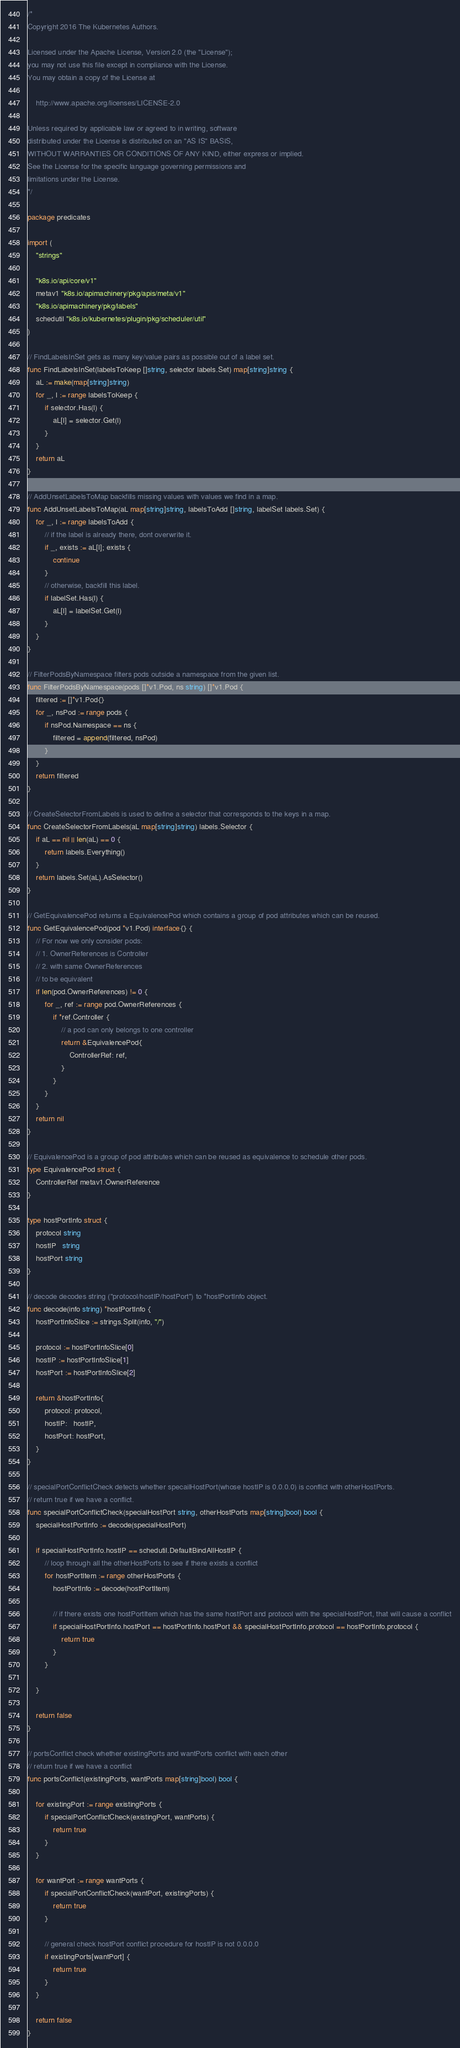<code> <loc_0><loc_0><loc_500><loc_500><_Go_>/*
Copyright 2016 The Kubernetes Authors.

Licensed under the Apache License, Version 2.0 (the "License");
you may not use this file except in compliance with the License.
You may obtain a copy of the License at

    http://www.apache.org/licenses/LICENSE-2.0

Unless required by applicable law or agreed to in writing, software
distributed under the License is distributed on an "AS IS" BASIS,
WITHOUT WARRANTIES OR CONDITIONS OF ANY KIND, either express or implied.
See the License for the specific language governing permissions and
limitations under the License.
*/

package predicates

import (
	"strings"

	"k8s.io/api/core/v1"
	metav1 "k8s.io/apimachinery/pkg/apis/meta/v1"
	"k8s.io/apimachinery/pkg/labels"
	schedutil "k8s.io/kubernetes/plugin/pkg/scheduler/util"
)

// FindLabelsInSet gets as many key/value pairs as possible out of a label set.
func FindLabelsInSet(labelsToKeep []string, selector labels.Set) map[string]string {
	aL := make(map[string]string)
	for _, l := range labelsToKeep {
		if selector.Has(l) {
			aL[l] = selector.Get(l)
		}
	}
	return aL
}

// AddUnsetLabelsToMap backfills missing values with values we find in a map.
func AddUnsetLabelsToMap(aL map[string]string, labelsToAdd []string, labelSet labels.Set) {
	for _, l := range labelsToAdd {
		// if the label is already there, dont overwrite it.
		if _, exists := aL[l]; exists {
			continue
		}
		// otherwise, backfill this label.
		if labelSet.Has(l) {
			aL[l] = labelSet.Get(l)
		}
	}
}

// FilterPodsByNamespace filters pods outside a namespace from the given list.
func FilterPodsByNamespace(pods []*v1.Pod, ns string) []*v1.Pod {
	filtered := []*v1.Pod{}
	for _, nsPod := range pods {
		if nsPod.Namespace == ns {
			filtered = append(filtered, nsPod)
		}
	}
	return filtered
}

// CreateSelectorFromLabels is used to define a selector that corresponds to the keys in a map.
func CreateSelectorFromLabels(aL map[string]string) labels.Selector {
	if aL == nil || len(aL) == 0 {
		return labels.Everything()
	}
	return labels.Set(aL).AsSelector()
}

// GetEquivalencePod returns a EquivalencePod which contains a group of pod attributes which can be reused.
func GetEquivalencePod(pod *v1.Pod) interface{} {
	// For now we only consider pods:
	// 1. OwnerReferences is Controller
	// 2. with same OwnerReferences
	// to be equivalent
	if len(pod.OwnerReferences) != 0 {
		for _, ref := range pod.OwnerReferences {
			if *ref.Controller {
				// a pod can only belongs to one controller
				return &EquivalencePod{
					ControllerRef: ref,
				}
			}
		}
	}
	return nil
}

// EquivalencePod is a group of pod attributes which can be reused as equivalence to schedule other pods.
type EquivalencePod struct {
	ControllerRef metav1.OwnerReference
}

type hostPortInfo struct {
	protocol string
	hostIP   string
	hostPort string
}

// decode decodes string ("protocol/hostIP/hostPort") to *hostPortInfo object.
func decode(info string) *hostPortInfo {
	hostPortInfoSlice := strings.Split(info, "/")

	protocol := hostPortInfoSlice[0]
	hostIP := hostPortInfoSlice[1]
	hostPort := hostPortInfoSlice[2]

	return &hostPortInfo{
		protocol: protocol,
		hostIP:   hostIP,
		hostPort: hostPort,
	}
}

// specialPortConflictCheck detects whether specailHostPort(whose hostIP is 0.0.0.0) is conflict with otherHostPorts.
// return true if we have a conflict.
func specialPortConflictCheck(specialHostPort string, otherHostPorts map[string]bool) bool {
	specialHostPortInfo := decode(specialHostPort)

	if specialHostPortInfo.hostIP == schedutil.DefaultBindAllHostIP {
		// loop through all the otherHostPorts to see if there exists a conflict
		for hostPortItem := range otherHostPorts {
			hostPortInfo := decode(hostPortItem)

			// if there exists one hostPortItem which has the same hostPort and protocol with the specialHostPort, that will cause a conflict
			if specialHostPortInfo.hostPort == hostPortInfo.hostPort && specialHostPortInfo.protocol == hostPortInfo.protocol {
				return true
			}
		}

	}

	return false
}

// portsConflict check whether existingPorts and wantPorts conflict with each other
// return true if we have a conflict
func portsConflict(existingPorts, wantPorts map[string]bool) bool {

	for existingPort := range existingPorts {
		if specialPortConflictCheck(existingPort, wantPorts) {
			return true
		}
	}

	for wantPort := range wantPorts {
		if specialPortConflictCheck(wantPort, existingPorts) {
			return true
		}

		// general check hostPort conflict procedure for hostIP is not 0.0.0.0
		if existingPorts[wantPort] {
			return true
		}
	}

	return false
}
</code> 